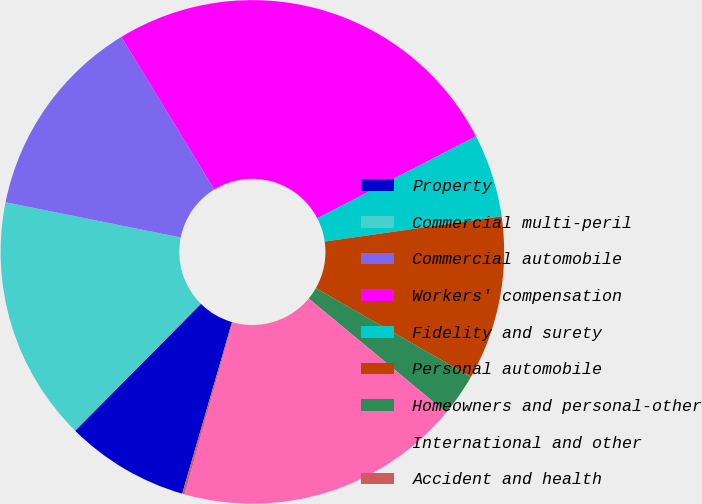<chart> <loc_0><loc_0><loc_500><loc_500><pie_chart><fcel>Property<fcel>Commercial multi-peril<fcel>Commercial automobile<fcel>Workers' compensation<fcel>Fidelity and surety<fcel>Personal automobile<fcel>Homeowners and personal-other<fcel>International and other<fcel>Accident and health<nl><fcel>7.94%<fcel>15.73%<fcel>13.13%<fcel>26.12%<fcel>5.34%<fcel>10.53%<fcel>2.74%<fcel>18.33%<fcel>0.15%<nl></chart> 